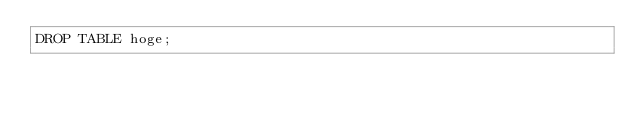Convert code to text. <code><loc_0><loc_0><loc_500><loc_500><_SQL_>DROP TABLE hoge;</code> 